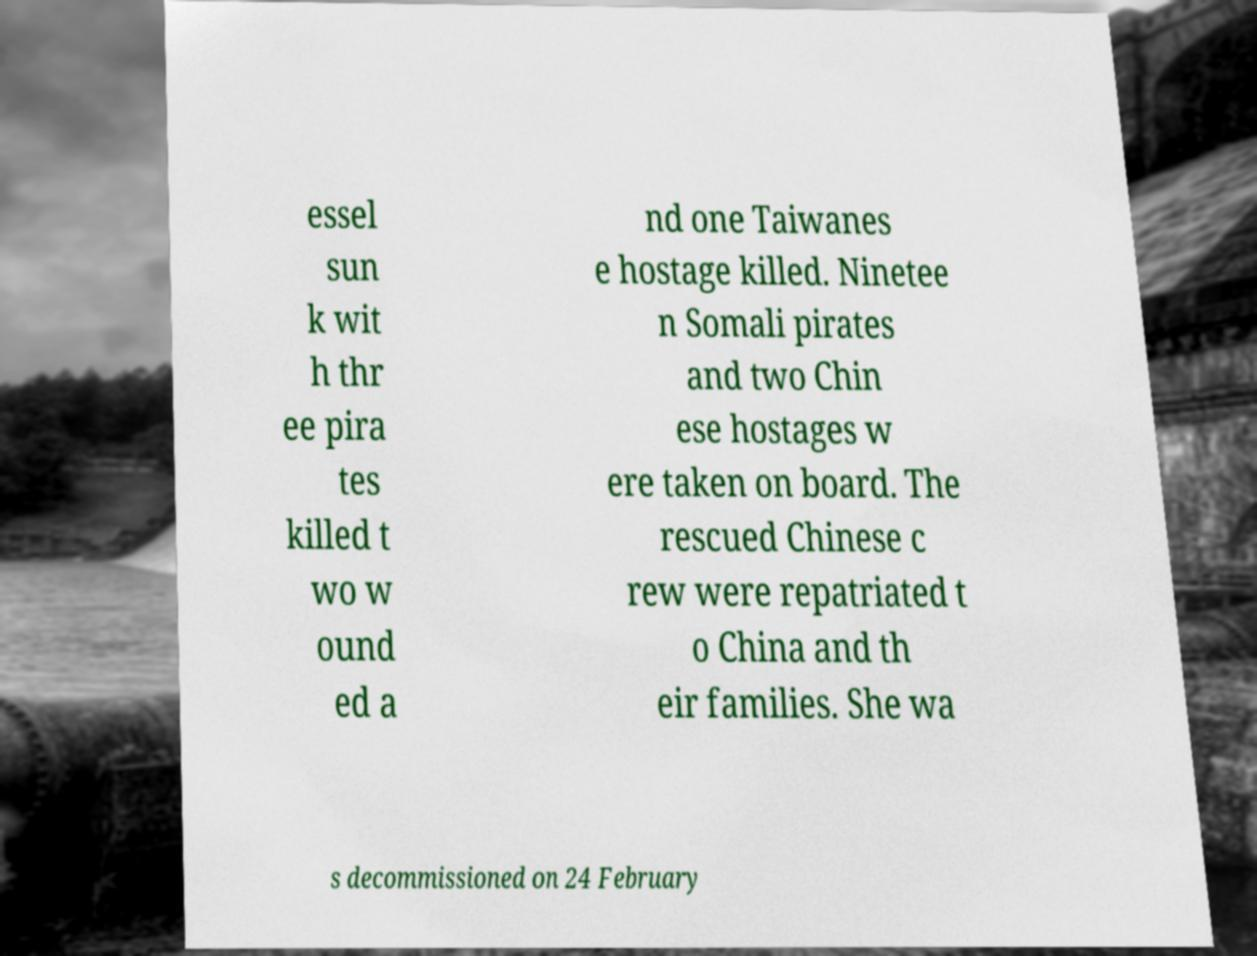For documentation purposes, I need the text within this image transcribed. Could you provide that? essel sun k wit h thr ee pira tes killed t wo w ound ed a nd one Taiwanes e hostage killed. Ninetee n Somali pirates and two Chin ese hostages w ere taken on board. The rescued Chinese c rew were repatriated t o China and th eir families. She wa s decommissioned on 24 February 